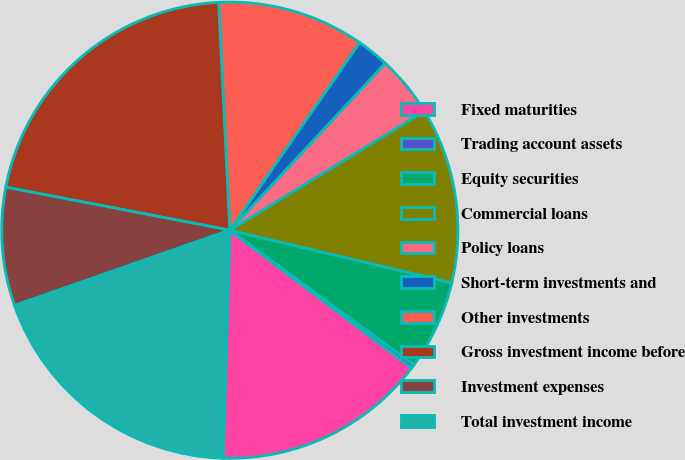<chart> <loc_0><loc_0><loc_500><loc_500><pie_chart><fcel>Fixed maturities<fcel>Trading account assets<fcel>Equity securities<fcel>Commercial loans<fcel>Policy loans<fcel>Short-term investments and<fcel>Other investments<fcel>Gross investment income before<fcel>Investment expenses<fcel>Total investment income<nl><fcel>15.15%<fcel>0.27%<fcel>6.35%<fcel>12.44%<fcel>4.33%<fcel>2.3%<fcel>10.41%<fcel>21.2%<fcel>8.38%<fcel>19.17%<nl></chart> 